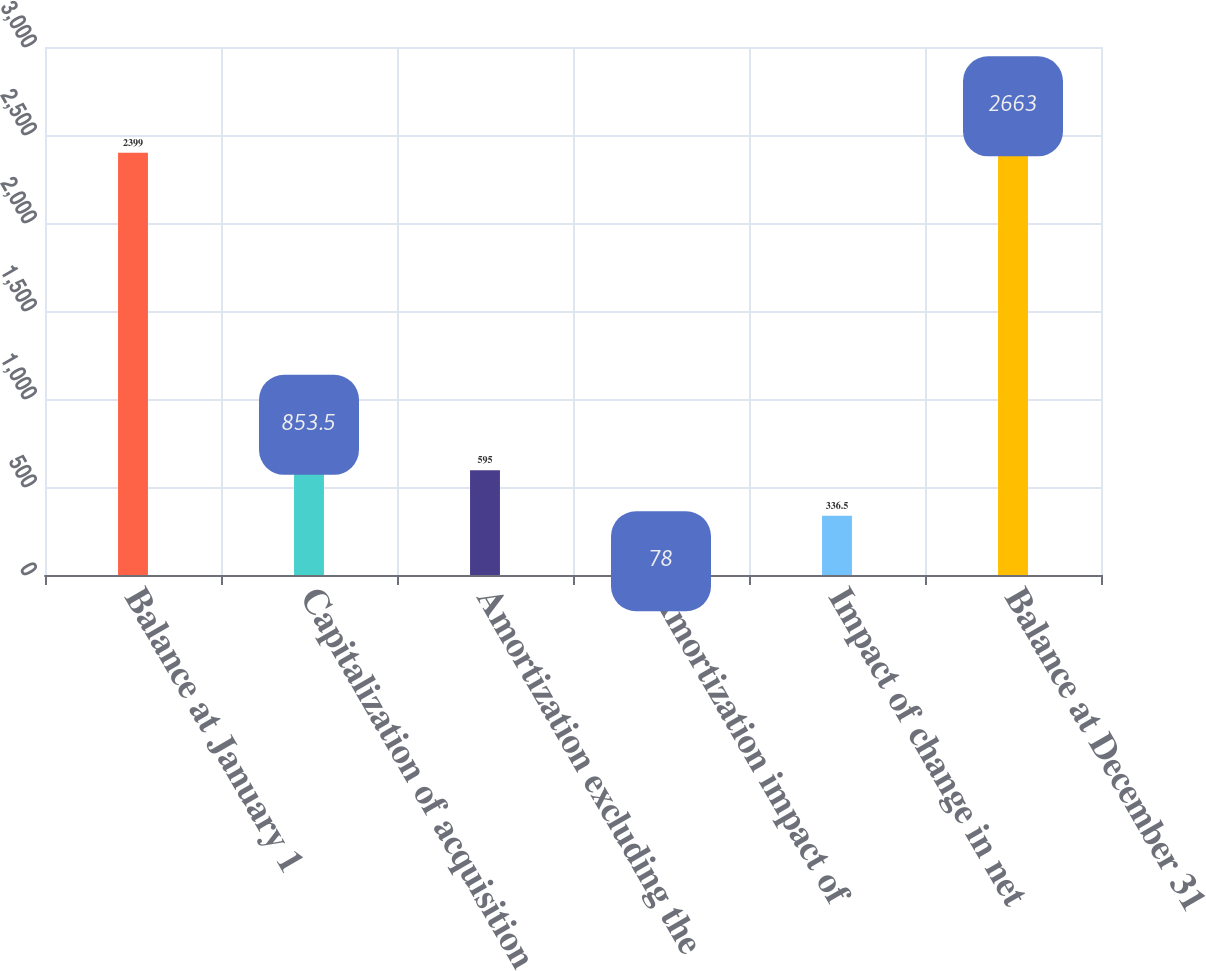<chart> <loc_0><loc_0><loc_500><loc_500><bar_chart><fcel>Balance at January 1<fcel>Capitalization of acquisition<fcel>Amortization excluding the<fcel>Amortization impact of<fcel>Impact of change in net<fcel>Balance at December 31<nl><fcel>2399<fcel>853.5<fcel>595<fcel>78<fcel>336.5<fcel>2663<nl></chart> 